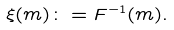<formula> <loc_0><loc_0><loc_500><loc_500>\xi ( m ) \colon = F ^ { - 1 } ( m ) .</formula> 